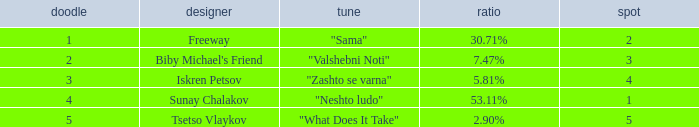Could you help me parse every detail presented in this table? {'header': ['doodle', 'designer', 'tune', 'ratio', 'spot'], 'rows': [['1', 'Freeway', '"Sama"', '30.71%', '2'], ['2', "Biby Michael's Friend", '"Valshebni Noti"', '7.47%', '3'], ['3', 'Iskren Petsov', '"Zashto se varna"', '5.81%', '4'], ['4', 'Sunay Chalakov', '"Neshto ludo"', '53.11%', '1'], ['5', 'Tsetso Vlaykov', '"What Does It Take"', '2.90%', '5']]} What is the highest draw when the place is less than 3 and the percentage is 30.71%? 1.0. 